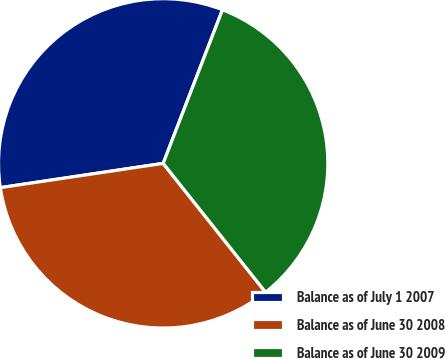Convert chart to OTSL. <chart><loc_0><loc_0><loc_500><loc_500><pie_chart><fcel>Balance as of July 1 2007<fcel>Balance as of June 30 2008<fcel>Balance as of June 30 2009<nl><fcel>33.22%<fcel>33.33%<fcel>33.45%<nl></chart> 